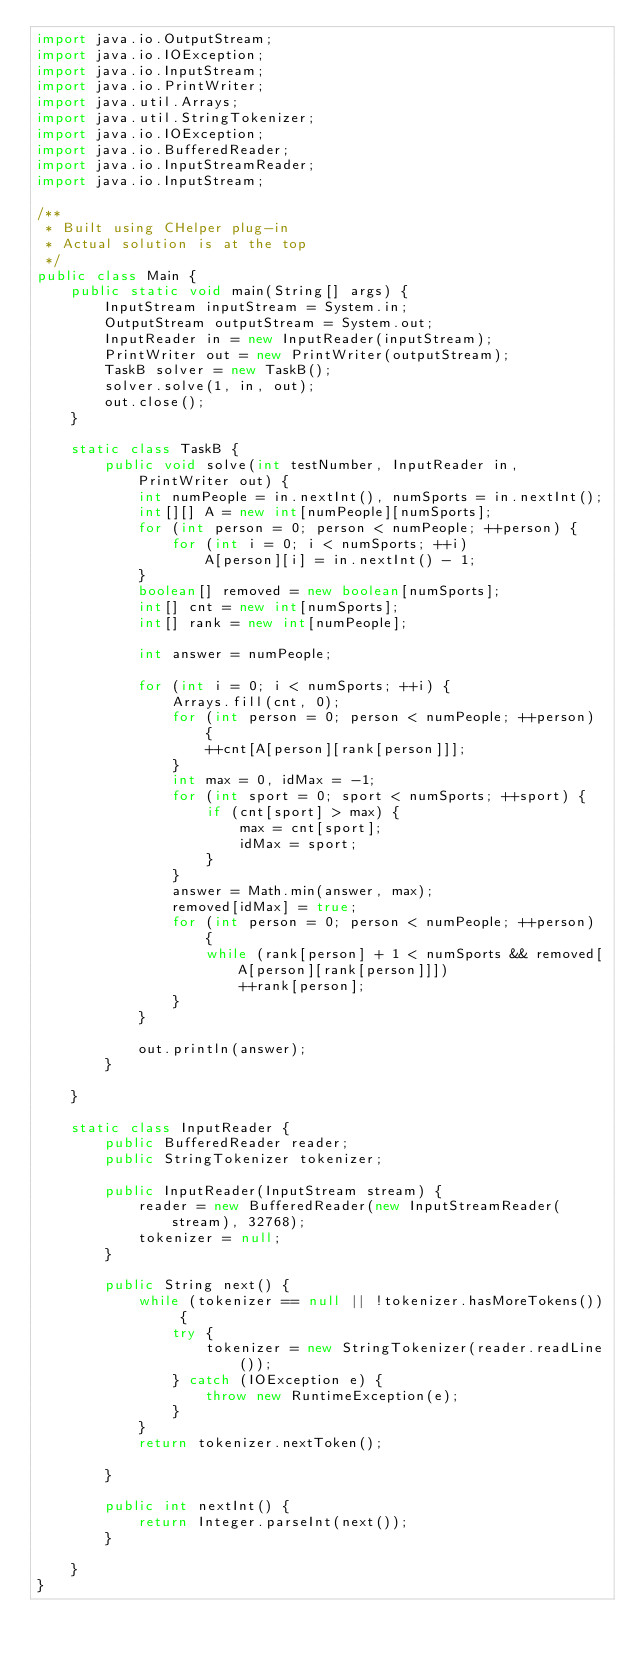Convert code to text. <code><loc_0><loc_0><loc_500><loc_500><_Java_>import java.io.OutputStream;
import java.io.IOException;
import java.io.InputStream;
import java.io.PrintWriter;
import java.util.Arrays;
import java.util.StringTokenizer;
import java.io.IOException;
import java.io.BufferedReader;
import java.io.InputStreamReader;
import java.io.InputStream;

/**
 * Built using CHelper plug-in
 * Actual solution is at the top
 */
public class Main {
    public static void main(String[] args) {
        InputStream inputStream = System.in;
        OutputStream outputStream = System.out;
        InputReader in = new InputReader(inputStream);
        PrintWriter out = new PrintWriter(outputStream);
        TaskB solver = new TaskB();
        solver.solve(1, in, out);
        out.close();
    }

    static class TaskB {
        public void solve(int testNumber, InputReader in, PrintWriter out) {
            int numPeople = in.nextInt(), numSports = in.nextInt();
            int[][] A = new int[numPeople][numSports];
            for (int person = 0; person < numPeople; ++person) {
                for (int i = 0; i < numSports; ++i)
                    A[person][i] = in.nextInt() - 1;
            }
            boolean[] removed = new boolean[numSports];
            int[] cnt = new int[numSports];
            int[] rank = new int[numPeople];

            int answer = numPeople;

            for (int i = 0; i < numSports; ++i) {
                Arrays.fill(cnt, 0);
                for (int person = 0; person < numPeople; ++person) {
                    ++cnt[A[person][rank[person]]];
                }
                int max = 0, idMax = -1;
                for (int sport = 0; sport < numSports; ++sport) {
                    if (cnt[sport] > max) {
                        max = cnt[sport];
                        idMax = sport;
                    }
                }
                answer = Math.min(answer, max);
                removed[idMax] = true;
                for (int person = 0; person < numPeople; ++person) {
                    while (rank[person] + 1 < numSports && removed[A[person][rank[person]]])
                        ++rank[person];
                }
            }

            out.println(answer);
        }

    }

    static class InputReader {
        public BufferedReader reader;
        public StringTokenizer tokenizer;

        public InputReader(InputStream stream) {
            reader = new BufferedReader(new InputStreamReader(stream), 32768);
            tokenizer = null;
        }

        public String next() {
            while (tokenizer == null || !tokenizer.hasMoreTokens()) {
                try {
                    tokenizer = new StringTokenizer(reader.readLine());
                } catch (IOException e) {
                    throw new RuntimeException(e);
                }
            }
            return tokenizer.nextToken();

        }

        public int nextInt() {
            return Integer.parseInt(next());
        }

    }
}

</code> 